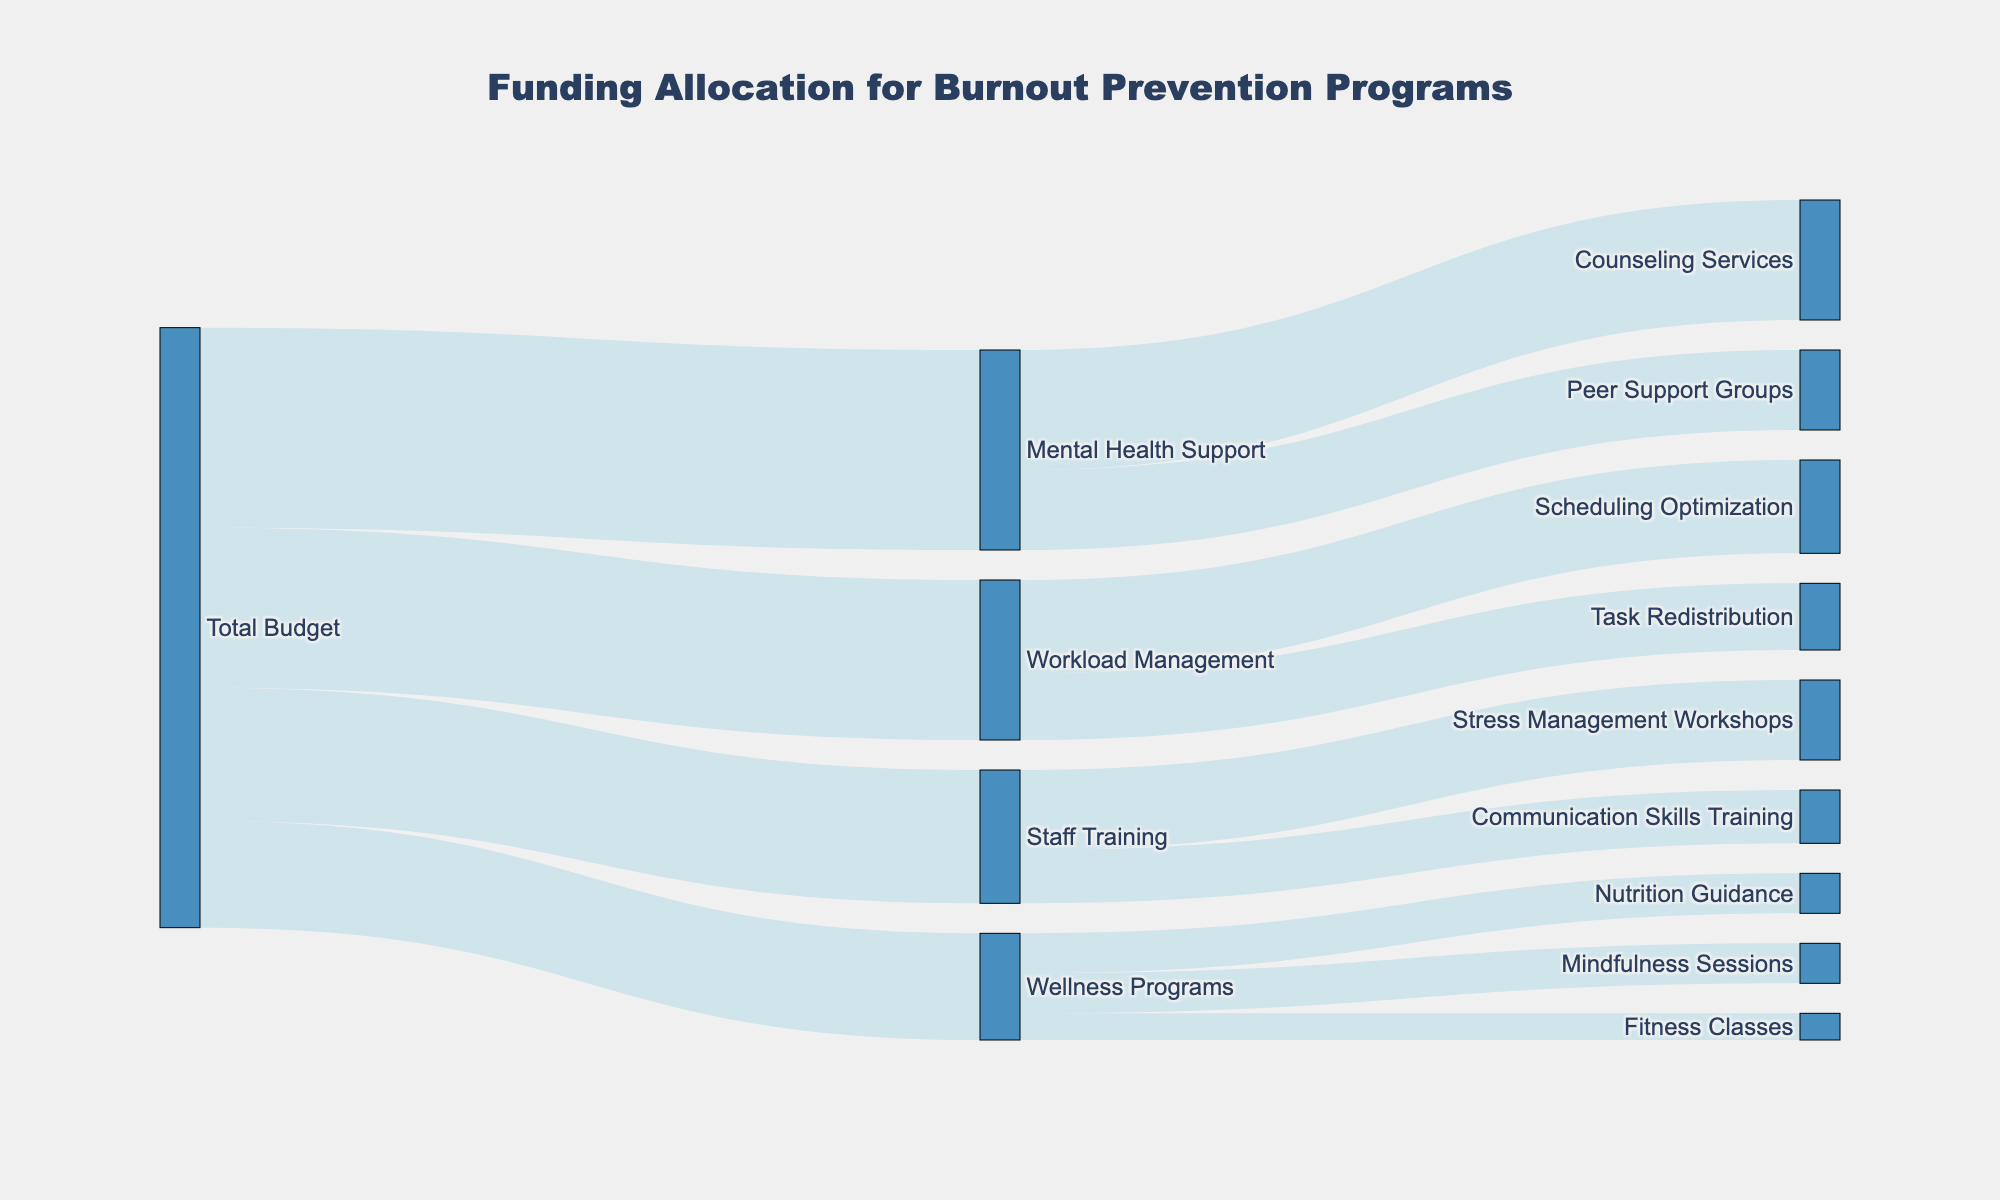Which burnout prevention area received the highest total funding? The areas receiving funding are Staff Training, Mental Health Support, Workload Management, and Wellness Programs. By checking their values (500000, 750000, 600000, and 400000 respectively), the highest value is 750000 for Mental Health Support.
Answer: Mental Health Support How much total funding is allocated to Staff Training? The budget for Staff Training is 500000. This information is shown by the link from Total Budget to Staff Training.
Answer: 500000 What is the combined budget for Mindfulness Sessions and Fitness Classes? The funding for Mindfulness Sessions and Fitness Classes is 150000 and 100000 respectively. Summing these gives us 150000 + 100000 = 250000.
Answer: 250000 Which specific initiative under Mental Health Support received less funding compared to Counseling Services? Counseling Services and Peer Support Groups are the two initiatives under Mental Health Support. Counseling Services received 450000, and Peer Support Groups received 300000. Peer Support Groups received less funding than Counseling Services.
Answer: Peer Support Groups What percentage of the total budget is allocated to Workload Management? The total budget is 2250000 (sum of all allocations). Workload Management received 600000. The percentage is (600000 / 2250000) * 100 = 26.67%.
Answer: 26.67% What is the difference in funding between Stress Management Workshops and Communication Skills Training? Stress Management Workshops received 300000, and Communication Skills Training received 200000. The difference is 300000 - 200000 = 100000.
Answer: 100000 Which specific initiative received the smallest amount of funding? The smallest values are 100000, 150000, and 150000 for Fitness Classes, Mindfulness Sessions, and Nutrition Guidance. Among these, Fitness Classes received 100000, which is the smallest.
Answer: Fitness Classes Compare the funding for Scheduling Optimization against Task Redistribution. Which received more funding? Scheduling Optimization received 350000, and Task Redistribution received 250000. Scheduling Optimization received more funding.
Answer: Scheduling Optimization How many specific initiatives are directly funded from Wellness Programs? There are three initiatives funded under Wellness Programs: Mindfulness Sessions, Fitness Classes, and Nutrition Guidance.
Answer: Three Calculate the total funding allocated to all the Wellness Programs initiatives. Mindfulness Sessions received 150000, Fitness Classes received 100000, and Nutrition Guidance received 150000. The total is 150000 + 100000 + 150000 = 400000.
Answer: 400000 